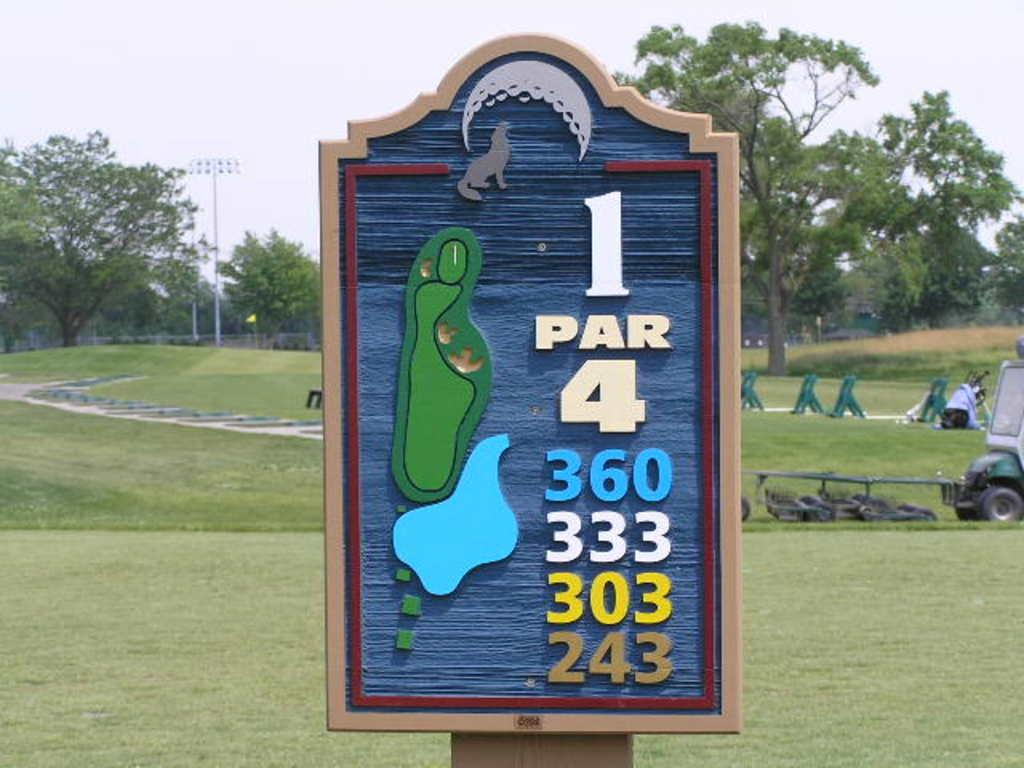What is on the board that is visible in the image? There is a board with numbers in the image. What type of vehicle can be seen in the image? There is a truck visible in the image. What type of seating is present in the image? There are benches in the image. What type of vegetation is present in the image? Grass and trees are visible in the image. What type of lighting is present in the image? There is a light attached to a pole in the image. What type of barrier is present in the image? There is a fence in the image. What is the condition of the sky in the image? The sky is visible in the image, and it appears cloudy. How many snails are crawling on the truck in the image? There are no snails visible in the image, so it is not possible to determine how many might be crawling on the truck. What type of cast is present in the image? There is no cast present in the image. 